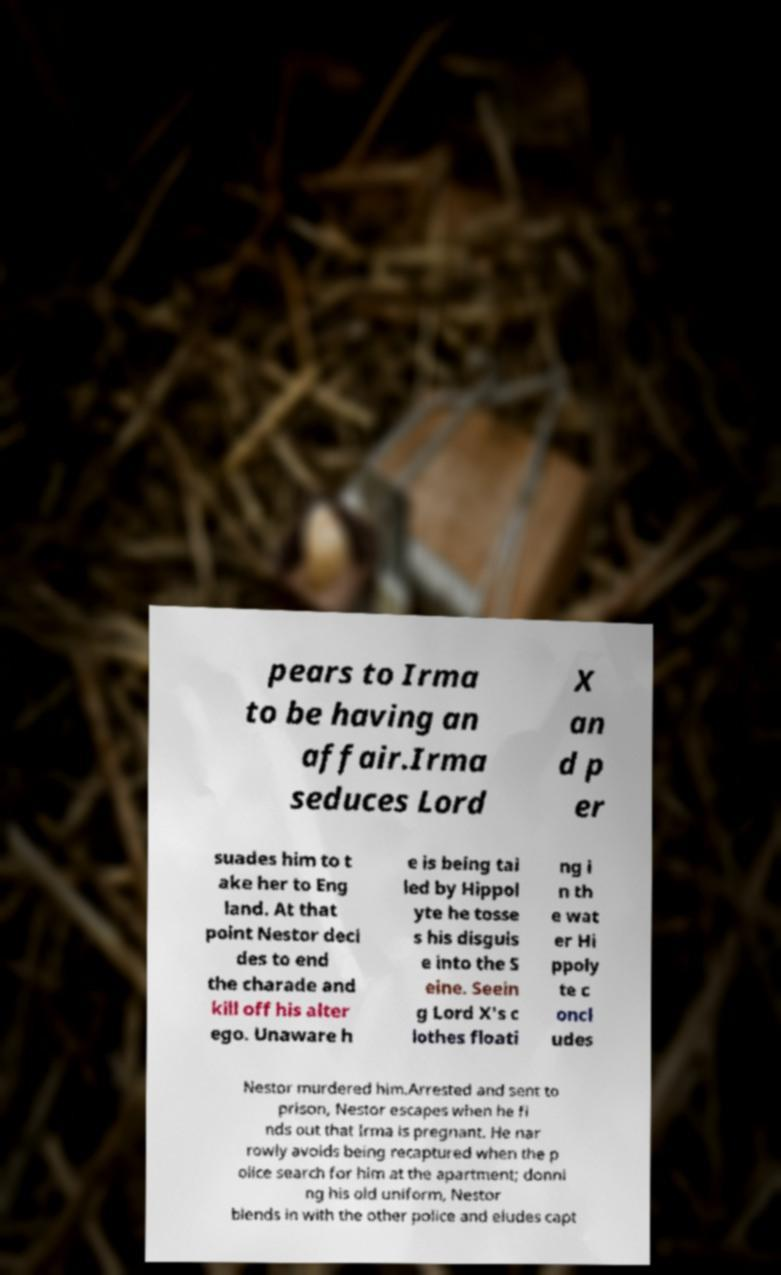For documentation purposes, I need the text within this image transcribed. Could you provide that? pears to Irma to be having an affair.Irma seduces Lord X an d p er suades him to t ake her to Eng land. At that point Nestor deci des to end the charade and kill off his alter ego. Unaware h e is being tai led by Hippol yte he tosse s his disguis e into the S eine. Seein g Lord X's c lothes floati ng i n th e wat er Hi ppoly te c oncl udes Nestor murdered him.Arrested and sent to prison, Nestor escapes when he fi nds out that Irma is pregnant. He nar rowly avoids being recaptured when the p olice search for him at the apartment; donni ng his old uniform, Nestor blends in with the other police and eludes capt 